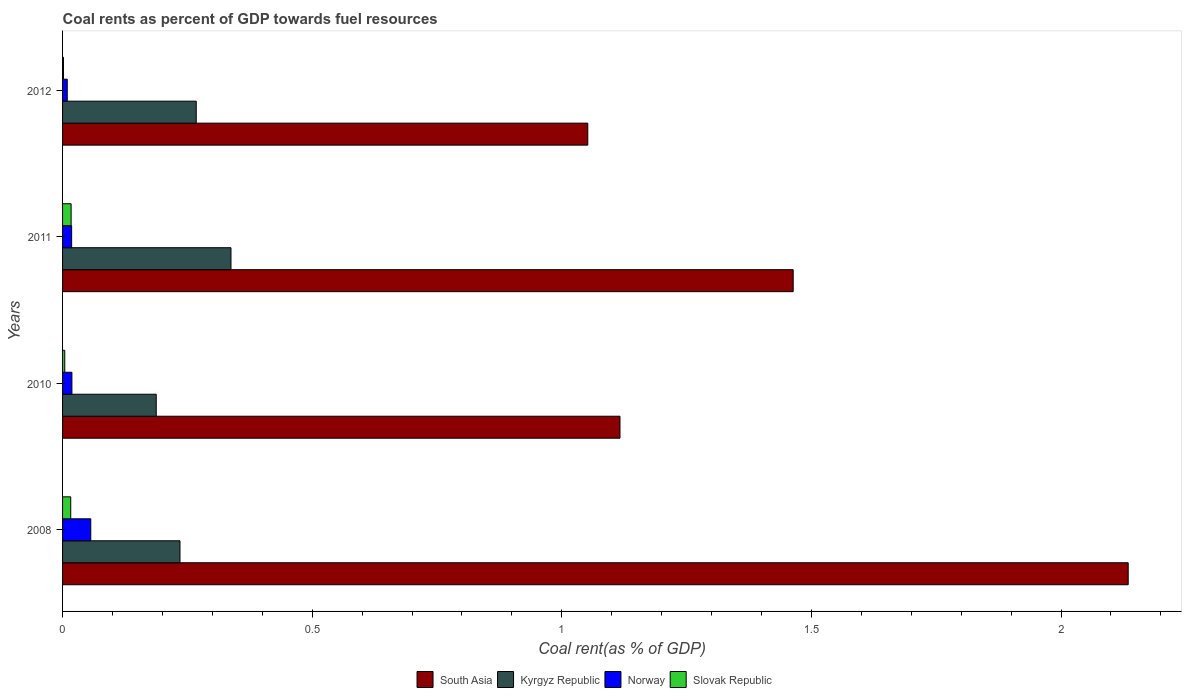How many different coloured bars are there?
Keep it short and to the point. 4. How many groups of bars are there?
Provide a succinct answer. 4. Are the number of bars per tick equal to the number of legend labels?
Your response must be concise. Yes. How many bars are there on the 4th tick from the bottom?
Your response must be concise. 4. What is the coal rent in Slovak Republic in 2011?
Your response must be concise. 0.02. Across all years, what is the maximum coal rent in South Asia?
Your answer should be very brief. 2.13. Across all years, what is the minimum coal rent in Slovak Republic?
Your answer should be compact. 0. In which year was the coal rent in South Asia minimum?
Make the answer very short. 2012. What is the total coal rent in Slovak Republic in the graph?
Give a very brief answer. 0.04. What is the difference between the coal rent in South Asia in 2011 and that in 2012?
Offer a terse response. 0.41. What is the difference between the coal rent in Slovak Republic in 2011 and the coal rent in Kyrgyz Republic in 2012?
Offer a terse response. -0.25. What is the average coal rent in Slovak Republic per year?
Your response must be concise. 0.01. In the year 2008, what is the difference between the coal rent in Slovak Republic and coal rent in South Asia?
Offer a very short reply. -2.12. In how many years, is the coal rent in Norway greater than 2 %?
Make the answer very short. 0. What is the ratio of the coal rent in Slovak Republic in 2011 to that in 2012?
Provide a short and direct response. 9.44. Is the coal rent in Kyrgyz Republic in 2008 less than that in 2011?
Offer a very short reply. Yes. What is the difference between the highest and the second highest coal rent in Kyrgyz Republic?
Provide a short and direct response. 0.07. What is the difference between the highest and the lowest coal rent in Norway?
Your response must be concise. 0.05. Is the sum of the coal rent in South Asia in 2008 and 2010 greater than the maximum coal rent in Kyrgyz Republic across all years?
Keep it short and to the point. Yes. What does the 1st bar from the top in 2011 represents?
Give a very brief answer. Slovak Republic. What does the 4th bar from the bottom in 2011 represents?
Give a very brief answer. Slovak Republic. Is it the case that in every year, the sum of the coal rent in Norway and coal rent in Kyrgyz Republic is greater than the coal rent in South Asia?
Make the answer very short. No. How many years are there in the graph?
Provide a succinct answer. 4. What is the difference between two consecutive major ticks on the X-axis?
Provide a succinct answer. 0.5. Are the values on the major ticks of X-axis written in scientific E-notation?
Ensure brevity in your answer.  No. Does the graph contain any zero values?
Your answer should be compact. No. Does the graph contain grids?
Ensure brevity in your answer.  No. How are the legend labels stacked?
Ensure brevity in your answer.  Horizontal. What is the title of the graph?
Your answer should be very brief. Coal rents as percent of GDP towards fuel resources. Does "Ecuador" appear as one of the legend labels in the graph?
Offer a terse response. No. What is the label or title of the X-axis?
Offer a very short reply. Coal rent(as % of GDP). What is the label or title of the Y-axis?
Make the answer very short. Years. What is the Coal rent(as % of GDP) of South Asia in 2008?
Make the answer very short. 2.13. What is the Coal rent(as % of GDP) in Kyrgyz Republic in 2008?
Make the answer very short. 0.24. What is the Coal rent(as % of GDP) of Norway in 2008?
Keep it short and to the point. 0.06. What is the Coal rent(as % of GDP) in Slovak Republic in 2008?
Offer a terse response. 0.02. What is the Coal rent(as % of GDP) in South Asia in 2010?
Provide a short and direct response. 1.12. What is the Coal rent(as % of GDP) of Kyrgyz Republic in 2010?
Make the answer very short. 0.19. What is the Coal rent(as % of GDP) of Norway in 2010?
Keep it short and to the point. 0.02. What is the Coal rent(as % of GDP) of Slovak Republic in 2010?
Ensure brevity in your answer.  0. What is the Coal rent(as % of GDP) in South Asia in 2011?
Provide a short and direct response. 1.46. What is the Coal rent(as % of GDP) in Kyrgyz Republic in 2011?
Provide a short and direct response. 0.34. What is the Coal rent(as % of GDP) in Norway in 2011?
Make the answer very short. 0.02. What is the Coal rent(as % of GDP) of Slovak Republic in 2011?
Your response must be concise. 0.02. What is the Coal rent(as % of GDP) in South Asia in 2012?
Keep it short and to the point. 1.05. What is the Coal rent(as % of GDP) of Kyrgyz Republic in 2012?
Your answer should be very brief. 0.27. What is the Coal rent(as % of GDP) of Norway in 2012?
Your answer should be very brief. 0.01. What is the Coal rent(as % of GDP) in Slovak Republic in 2012?
Give a very brief answer. 0. Across all years, what is the maximum Coal rent(as % of GDP) in South Asia?
Ensure brevity in your answer.  2.13. Across all years, what is the maximum Coal rent(as % of GDP) in Kyrgyz Republic?
Keep it short and to the point. 0.34. Across all years, what is the maximum Coal rent(as % of GDP) of Norway?
Your answer should be compact. 0.06. Across all years, what is the maximum Coal rent(as % of GDP) of Slovak Republic?
Your answer should be compact. 0.02. Across all years, what is the minimum Coal rent(as % of GDP) of South Asia?
Your answer should be very brief. 1.05. Across all years, what is the minimum Coal rent(as % of GDP) of Kyrgyz Republic?
Provide a succinct answer. 0.19. Across all years, what is the minimum Coal rent(as % of GDP) in Norway?
Offer a terse response. 0.01. Across all years, what is the minimum Coal rent(as % of GDP) of Slovak Republic?
Ensure brevity in your answer.  0. What is the total Coal rent(as % of GDP) in South Asia in the graph?
Offer a terse response. 5.77. What is the total Coal rent(as % of GDP) in Kyrgyz Republic in the graph?
Offer a very short reply. 1.03. What is the total Coal rent(as % of GDP) in Norway in the graph?
Your response must be concise. 0.1. What is the total Coal rent(as % of GDP) in Slovak Republic in the graph?
Provide a short and direct response. 0.04. What is the difference between the Coal rent(as % of GDP) in South Asia in 2008 and that in 2010?
Ensure brevity in your answer.  1.02. What is the difference between the Coal rent(as % of GDP) in Kyrgyz Republic in 2008 and that in 2010?
Your answer should be compact. 0.05. What is the difference between the Coal rent(as % of GDP) of Norway in 2008 and that in 2010?
Offer a very short reply. 0.04. What is the difference between the Coal rent(as % of GDP) of Slovak Republic in 2008 and that in 2010?
Provide a succinct answer. 0.01. What is the difference between the Coal rent(as % of GDP) in South Asia in 2008 and that in 2011?
Provide a short and direct response. 0.67. What is the difference between the Coal rent(as % of GDP) in Kyrgyz Republic in 2008 and that in 2011?
Keep it short and to the point. -0.1. What is the difference between the Coal rent(as % of GDP) in Norway in 2008 and that in 2011?
Provide a succinct answer. 0.04. What is the difference between the Coal rent(as % of GDP) of Slovak Republic in 2008 and that in 2011?
Your response must be concise. -0. What is the difference between the Coal rent(as % of GDP) of South Asia in 2008 and that in 2012?
Your answer should be compact. 1.08. What is the difference between the Coal rent(as % of GDP) of Kyrgyz Republic in 2008 and that in 2012?
Offer a terse response. -0.03. What is the difference between the Coal rent(as % of GDP) in Norway in 2008 and that in 2012?
Give a very brief answer. 0.05. What is the difference between the Coal rent(as % of GDP) of Slovak Republic in 2008 and that in 2012?
Offer a terse response. 0.01. What is the difference between the Coal rent(as % of GDP) of South Asia in 2010 and that in 2011?
Your answer should be compact. -0.35. What is the difference between the Coal rent(as % of GDP) in Kyrgyz Republic in 2010 and that in 2011?
Keep it short and to the point. -0.15. What is the difference between the Coal rent(as % of GDP) in Slovak Republic in 2010 and that in 2011?
Make the answer very short. -0.01. What is the difference between the Coal rent(as % of GDP) of South Asia in 2010 and that in 2012?
Keep it short and to the point. 0.06. What is the difference between the Coal rent(as % of GDP) of Kyrgyz Republic in 2010 and that in 2012?
Provide a short and direct response. -0.08. What is the difference between the Coal rent(as % of GDP) in Norway in 2010 and that in 2012?
Your answer should be compact. 0.01. What is the difference between the Coal rent(as % of GDP) in Slovak Republic in 2010 and that in 2012?
Your answer should be very brief. 0. What is the difference between the Coal rent(as % of GDP) of South Asia in 2011 and that in 2012?
Your answer should be compact. 0.41. What is the difference between the Coal rent(as % of GDP) in Kyrgyz Republic in 2011 and that in 2012?
Your answer should be compact. 0.07. What is the difference between the Coal rent(as % of GDP) of Norway in 2011 and that in 2012?
Ensure brevity in your answer.  0.01. What is the difference between the Coal rent(as % of GDP) of Slovak Republic in 2011 and that in 2012?
Your response must be concise. 0.02. What is the difference between the Coal rent(as % of GDP) of South Asia in 2008 and the Coal rent(as % of GDP) of Kyrgyz Republic in 2010?
Provide a succinct answer. 1.95. What is the difference between the Coal rent(as % of GDP) in South Asia in 2008 and the Coal rent(as % of GDP) in Norway in 2010?
Offer a terse response. 2.12. What is the difference between the Coal rent(as % of GDP) of South Asia in 2008 and the Coal rent(as % of GDP) of Slovak Republic in 2010?
Provide a short and direct response. 2.13. What is the difference between the Coal rent(as % of GDP) of Kyrgyz Republic in 2008 and the Coal rent(as % of GDP) of Norway in 2010?
Your answer should be very brief. 0.22. What is the difference between the Coal rent(as % of GDP) of Kyrgyz Republic in 2008 and the Coal rent(as % of GDP) of Slovak Republic in 2010?
Your answer should be compact. 0.23. What is the difference between the Coal rent(as % of GDP) of Norway in 2008 and the Coal rent(as % of GDP) of Slovak Republic in 2010?
Offer a very short reply. 0.05. What is the difference between the Coal rent(as % of GDP) in South Asia in 2008 and the Coal rent(as % of GDP) in Kyrgyz Republic in 2011?
Provide a succinct answer. 1.8. What is the difference between the Coal rent(as % of GDP) in South Asia in 2008 and the Coal rent(as % of GDP) in Norway in 2011?
Offer a very short reply. 2.12. What is the difference between the Coal rent(as % of GDP) in South Asia in 2008 and the Coal rent(as % of GDP) in Slovak Republic in 2011?
Give a very brief answer. 2.12. What is the difference between the Coal rent(as % of GDP) of Kyrgyz Republic in 2008 and the Coal rent(as % of GDP) of Norway in 2011?
Your response must be concise. 0.22. What is the difference between the Coal rent(as % of GDP) in Kyrgyz Republic in 2008 and the Coal rent(as % of GDP) in Slovak Republic in 2011?
Provide a succinct answer. 0.22. What is the difference between the Coal rent(as % of GDP) in Norway in 2008 and the Coal rent(as % of GDP) in Slovak Republic in 2011?
Ensure brevity in your answer.  0.04. What is the difference between the Coal rent(as % of GDP) in South Asia in 2008 and the Coal rent(as % of GDP) in Kyrgyz Republic in 2012?
Give a very brief answer. 1.87. What is the difference between the Coal rent(as % of GDP) in South Asia in 2008 and the Coal rent(as % of GDP) in Norway in 2012?
Ensure brevity in your answer.  2.13. What is the difference between the Coal rent(as % of GDP) in South Asia in 2008 and the Coal rent(as % of GDP) in Slovak Republic in 2012?
Keep it short and to the point. 2.13. What is the difference between the Coal rent(as % of GDP) of Kyrgyz Republic in 2008 and the Coal rent(as % of GDP) of Norway in 2012?
Provide a succinct answer. 0.23. What is the difference between the Coal rent(as % of GDP) in Kyrgyz Republic in 2008 and the Coal rent(as % of GDP) in Slovak Republic in 2012?
Provide a short and direct response. 0.23. What is the difference between the Coal rent(as % of GDP) of Norway in 2008 and the Coal rent(as % of GDP) of Slovak Republic in 2012?
Your response must be concise. 0.05. What is the difference between the Coal rent(as % of GDP) of South Asia in 2010 and the Coal rent(as % of GDP) of Kyrgyz Republic in 2011?
Offer a terse response. 0.78. What is the difference between the Coal rent(as % of GDP) of South Asia in 2010 and the Coal rent(as % of GDP) of Norway in 2011?
Give a very brief answer. 1.1. What is the difference between the Coal rent(as % of GDP) in South Asia in 2010 and the Coal rent(as % of GDP) in Slovak Republic in 2011?
Offer a very short reply. 1.1. What is the difference between the Coal rent(as % of GDP) of Kyrgyz Republic in 2010 and the Coal rent(as % of GDP) of Norway in 2011?
Give a very brief answer. 0.17. What is the difference between the Coal rent(as % of GDP) in Kyrgyz Republic in 2010 and the Coal rent(as % of GDP) in Slovak Republic in 2011?
Offer a terse response. 0.17. What is the difference between the Coal rent(as % of GDP) in Norway in 2010 and the Coal rent(as % of GDP) in Slovak Republic in 2011?
Your answer should be compact. 0. What is the difference between the Coal rent(as % of GDP) in South Asia in 2010 and the Coal rent(as % of GDP) in Kyrgyz Republic in 2012?
Keep it short and to the point. 0.85. What is the difference between the Coal rent(as % of GDP) in South Asia in 2010 and the Coal rent(as % of GDP) in Norway in 2012?
Your answer should be very brief. 1.11. What is the difference between the Coal rent(as % of GDP) of South Asia in 2010 and the Coal rent(as % of GDP) of Slovak Republic in 2012?
Give a very brief answer. 1.11. What is the difference between the Coal rent(as % of GDP) of Kyrgyz Republic in 2010 and the Coal rent(as % of GDP) of Norway in 2012?
Your answer should be compact. 0.18. What is the difference between the Coal rent(as % of GDP) of Kyrgyz Republic in 2010 and the Coal rent(as % of GDP) of Slovak Republic in 2012?
Ensure brevity in your answer.  0.19. What is the difference between the Coal rent(as % of GDP) in Norway in 2010 and the Coal rent(as % of GDP) in Slovak Republic in 2012?
Your answer should be very brief. 0.02. What is the difference between the Coal rent(as % of GDP) of South Asia in 2011 and the Coal rent(as % of GDP) of Kyrgyz Republic in 2012?
Keep it short and to the point. 1.2. What is the difference between the Coal rent(as % of GDP) of South Asia in 2011 and the Coal rent(as % of GDP) of Norway in 2012?
Offer a terse response. 1.45. What is the difference between the Coal rent(as % of GDP) of South Asia in 2011 and the Coal rent(as % of GDP) of Slovak Republic in 2012?
Provide a succinct answer. 1.46. What is the difference between the Coal rent(as % of GDP) in Kyrgyz Republic in 2011 and the Coal rent(as % of GDP) in Norway in 2012?
Provide a succinct answer. 0.33. What is the difference between the Coal rent(as % of GDP) of Kyrgyz Republic in 2011 and the Coal rent(as % of GDP) of Slovak Republic in 2012?
Your answer should be very brief. 0.34. What is the difference between the Coal rent(as % of GDP) of Norway in 2011 and the Coal rent(as % of GDP) of Slovak Republic in 2012?
Ensure brevity in your answer.  0.02. What is the average Coal rent(as % of GDP) of South Asia per year?
Give a very brief answer. 1.44. What is the average Coal rent(as % of GDP) of Kyrgyz Republic per year?
Offer a very short reply. 0.26. What is the average Coal rent(as % of GDP) of Norway per year?
Your answer should be compact. 0.03. What is the average Coal rent(as % of GDP) of Slovak Republic per year?
Provide a short and direct response. 0.01. In the year 2008, what is the difference between the Coal rent(as % of GDP) of South Asia and Coal rent(as % of GDP) of Kyrgyz Republic?
Provide a short and direct response. 1.9. In the year 2008, what is the difference between the Coal rent(as % of GDP) of South Asia and Coal rent(as % of GDP) of Norway?
Offer a very short reply. 2.08. In the year 2008, what is the difference between the Coal rent(as % of GDP) of South Asia and Coal rent(as % of GDP) of Slovak Republic?
Give a very brief answer. 2.12. In the year 2008, what is the difference between the Coal rent(as % of GDP) in Kyrgyz Republic and Coal rent(as % of GDP) in Norway?
Your response must be concise. 0.18. In the year 2008, what is the difference between the Coal rent(as % of GDP) in Kyrgyz Republic and Coal rent(as % of GDP) in Slovak Republic?
Offer a terse response. 0.22. In the year 2008, what is the difference between the Coal rent(as % of GDP) of Norway and Coal rent(as % of GDP) of Slovak Republic?
Offer a very short reply. 0.04. In the year 2010, what is the difference between the Coal rent(as % of GDP) of South Asia and Coal rent(as % of GDP) of Kyrgyz Republic?
Ensure brevity in your answer.  0.93. In the year 2010, what is the difference between the Coal rent(as % of GDP) in South Asia and Coal rent(as % of GDP) in Norway?
Offer a terse response. 1.1. In the year 2010, what is the difference between the Coal rent(as % of GDP) in South Asia and Coal rent(as % of GDP) in Slovak Republic?
Provide a succinct answer. 1.11. In the year 2010, what is the difference between the Coal rent(as % of GDP) in Kyrgyz Republic and Coal rent(as % of GDP) in Norway?
Offer a terse response. 0.17. In the year 2010, what is the difference between the Coal rent(as % of GDP) of Kyrgyz Republic and Coal rent(as % of GDP) of Slovak Republic?
Make the answer very short. 0.18. In the year 2010, what is the difference between the Coal rent(as % of GDP) of Norway and Coal rent(as % of GDP) of Slovak Republic?
Ensure brevity in your answer.  0.01. In the year 2011, what is the difference between the Coal rent(as % of GDP) in South Asia and Coal rent(as % of GDP) in Kyrgyz Republic?
Your answer should be very brief. 1.13. In the year 2011, what is the difference between the Coal rent(as % of GDP) in South Asia and Coal rent(as % of GDP) in Norway?
Make the answer very short. 1.45. In the year 2011, what is the difference between the Coal rent(as % of GDP) in South Asia and Coal rent(as % of GDP) in Slovak Republic?
Provide a succinct answer. 1.45. In the year 2011, what is the difference between the Coal rent(as % of GDP) in Kyrgyz Republic and Coal rent(as % of GDP) in Norway?
Provide a short and direct response. 0.32. In the year 2011, what is the difference between the Coal rent(as % of GDP) in Kyrgyz Republic and Coal rent(as % of GDP) in Slovak Republic?
Keep it short and to the point. 0.32. In the year 2012, what is the difference between the Coal rent(as % of GDP) of South Asia and Coal rent(as % of GDP) of Kyrgyz Republic?
Your response must be concise. 0.78. In the year 2012, what is the difference between the Coal rent(as % of GDP) in South Asia and Coal rent(as % of GDP) in Norway?
Ensure brevity in your answer.  1.04. In the year 2012, what is the difference between the Coal rent(as % of GDP) of South Asia and Coal rent(as % of GDP) of Slovak Republic?
Offer a terse response. 1.05. In the year 2012, what is the difference between the Coal rent(as % of GDP) of Kyrgyz Republic and Coal rent(as % of GDP) of Norway?
Make the answer very short. 0.26. In the year 2012, what is the difference between the Coal rent(as % of GDP) in Kyrgyz Republic and Coal rent(as % of GDP) in Slovak Republic?
Make the answer very short. 0.27. In the year 2012, what is the difference between the Coal rent(as % of GDP) of Norway and Coal rent(as % of GDP) of Slovak Republic?
Offer a terse response. 0.01. What is the ratio of the Coal rent(as % of GDP) in South Asia in 2008 to that in 2010?
Give a very brief answer. 1.91. What is the ratio of the Coal rent(as % of GDP) of Kyrgyz Republic in 2008 to that in 2010?
Your response must be concise. 1.25. What is the ratio of the Coal rent(as % of GDP) of Norway in 2008 to that in 2010?
Provide a short and direct response. 3.02. What is the ratio of the Coal rent(as % of GDP) of Slovak Republic in 2008 to that in 2010?
Keep it short and to the point. 3.73. What is the ratio of the Coal rent(as % of GDP) of South Asia in 2008 to that in 2011?
Provide a succinct answer. 1.46. What is the ratio of the Coal rent(as % of GDP) in Kyrgyz Republic in 2008 to that in 2011?
Offer a very short reply. 0.7. What is the ratio of the Coal rent(as % of GDP) of Norway in 2008 to that in 2011?
Your answer should be compact. 3.11. What is the ratio of the Coal rent(as % of GDP) in Slovak Republic in 2008 to that in 2011?
Provide a succinct answer. 0.95. What is the ratio of the Coal rent(as % of GDP) in South Asia in 2008 to that in 2012?
Provide a succinct answer. 2.03. What is the ratio of the Coal rent(as % of GDP) of Kyrgyz Republic in 2008 to that in 2012?
Your answer should be compact. 0.88. What is the ratio of the Coal rent(as % of GDP) of Norway in 2008 to that in 2012?
Provide a succinct answer. 6.02. What is the ratio of the Coal rent(as % of GDP) of Slovak Republic in 2008 to that in 2012?
Offer a very short reply. 9.01. What is the ratio of the Coal rent(as % of GDP) of South Asia in 2010 to that in 2011?
Provide a succinct answer. 0.76. What is the ratio of the Coal rent(as % of GDP) in Kyrgyz Republic in 2010 to that in 2011?
Your answer should be very brief. 0.56. What is the ratio of the Coal rent(as % of GDP) in Norway in 2010 to that in 2011?
Your answer should be compact. 1.03. What is the ratio of the Coal rent(as % of GDP) of Slovak Republic in 2010 to that in 2011?
Offer a terse response. 0.26. What is the ratio of the Coal rent(as % of GDP) in South Asia in 2010 to that in 2012?
Offer a very short reply. 1.06. What is the ratio of the Coal rent(as % of GDP) of Kyrgyz Republic in 2010 to that in 2012?
Keep it short and to the point. 0.7. What is the ratio of the Coal rent(as % of GDP) in Norway in 2010 to that in 2012?
Make the answer very short. 1.99. What is the ratio of the Coal rent(as % of GDP) in Slovak Republic in 2010 to that in 2012?
Make the answer very short. 2.42. What is the ratio of the Coal rent(as % of GDP) in South Asia in 2011 to that in 2012?
Provide a succinct answer. 1.39. What is the ratio of the Coal rent(as % of GDP) of Kyrgyz Republic in 2011 to that in 2012?
Offer a very short reply. 1.26. What is the ratio of the Coal rent(as % of GDP) of Norway in 2011 to that in 2012?
Give a very brief answer. 1.94. What is the ratio of the Coal rent(as % of GDP) in Slovak Republic in 2011 to that in 2012?
Offer a very short reply. 9.44. What is the difference between the highest and the second highest Coal rent(as % of GDP) of South Asia?
Give a very brief answer. 0.67. What is the difference between the highest and the second highest Coal rent(as % of GDP) of Kyrgyz Republic?
Make the answer very short. 0.07. What is the difference between the highest and the second highest Coal rent(as % of GDP) in Norway?
Ensure brevity in your answer.  0.04. What is the difference between the highest and the second highest Coal rent(as % of GDP) in Slovak Republic?
Give a very brief answer. 0. What is the difference between the highest and the lowest Coal rent(as % of GDP) of South Asia?
Provide a short and direct response. 1.08. What is the difference between the highest and the lowest Coal rent(as % of GDP) of Kyrgyz Republic?
Provide a succinct answer. 0.15. What is the difference between the highest and the lowest Coal rent(as % of GDP) of Norway?
Provide a short and direct response. 0.05. What is the difference between the highest and the lowest Coal rent(as % of GDP) of Slovak Republic?
Your answer should be very brief. 0.02. 